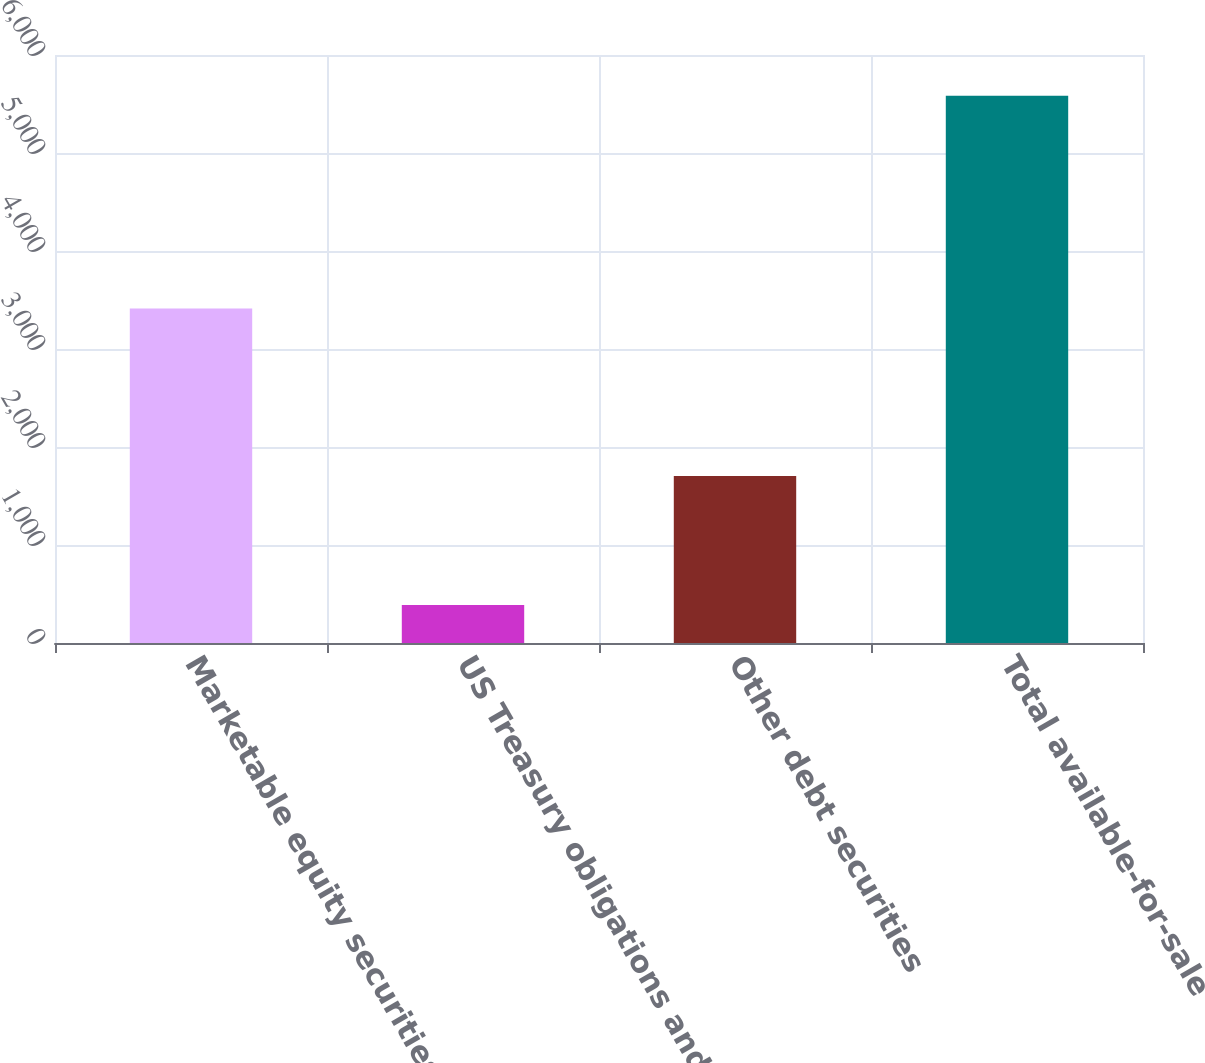<chart> <loc_0><loc_0><loc_500><loc_500><bar_chart><fcel>Marketable equity securities<fcel>US Treasury obligations and<fcel>Other debt securities<fcel>Total available-for-sale<nl><fcel>3413<fcel>387<fcel>1705<fcel>5585<nl></chart> 